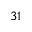<formula> <loc_0><loc_0><loc_500><loc_500>3 1</formula> 